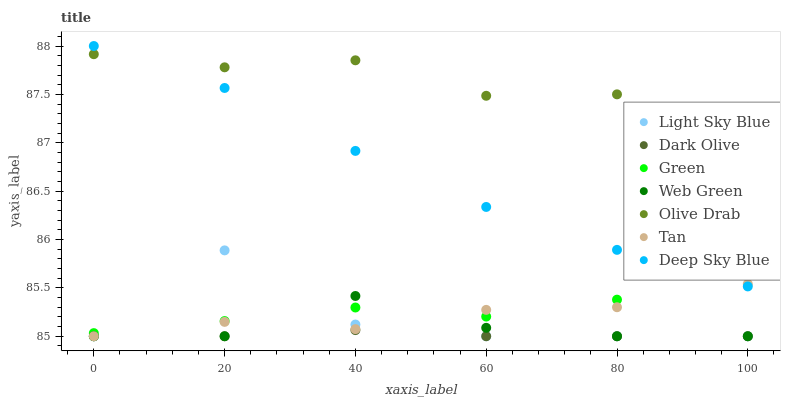Does Dark Olive have the minimum area under the curve?
Answer yes or no. Yes. Does Olive Drab have the maximum area under the curve?
Answer yes or no. Yes. Does Web Green have the minimum area under the curve?
Answer yes or no. No. Does Web Green have the maximum area under the curve?
Answer yes or no. No. Is Dark Olive the smoothest?
Answer yes or no. Yes. Is Light Sky Blue the roughest?
Answer yes or no. Yes. Is Web Green the smoothest?
Answer yes or no. No. Is Web Green the roughest?
Answer yes or no. No. Does Dark Olive have the lowest value?
Answer yes or no. Yes. Does Green have the lowest value?
Answer yes or no. No. Does Deep Sky Blue have the highest value?
Answer yes or no. Yes. Does Web Green have the highest value?
Answer yes or no. No. Is Dark Olive less than Olive Drab?
Answer yes or no. Yes. Is Deep Sky Blue greater than Light Sky Blue?
Answer yes or no. Yes. Does Tan intersect Deep Sky Blue?
Answer yes or no. Yes. Is Tan less than Deep Sky Blue?
Answer yes or no. No. Is Tan greater than Deep Sky Blue?
Answer yes or no. No. Does Dark Olive intersect Olive Drab?
Answer yes or no. No. 